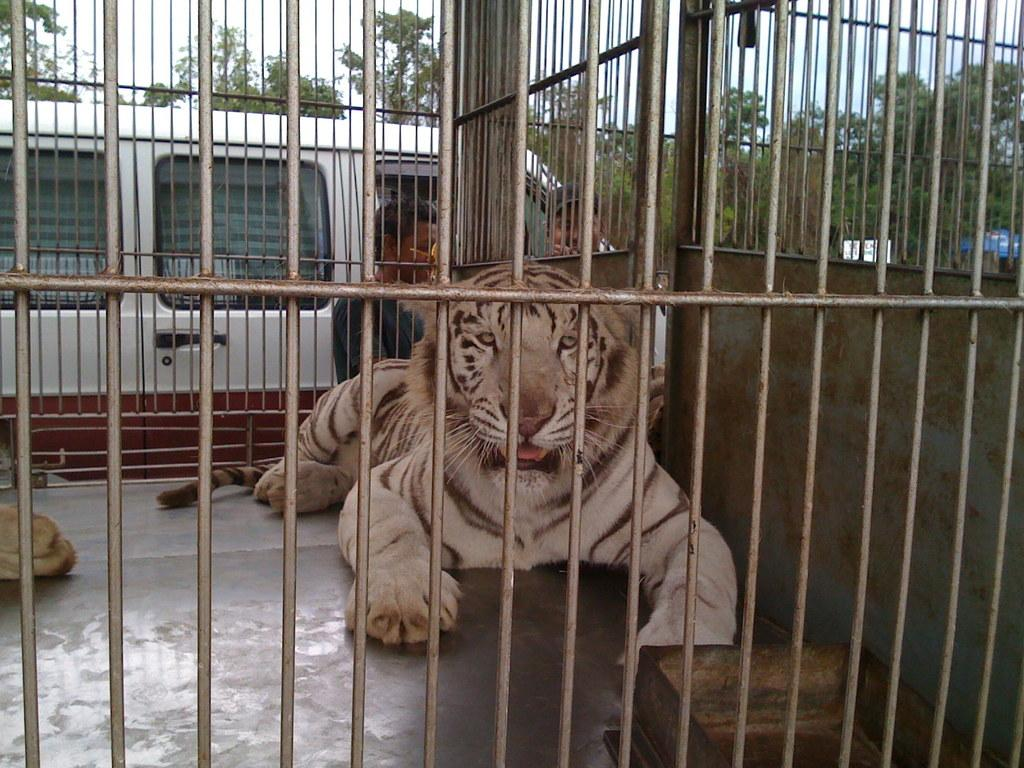What type of enclosure is present in the image? There is an iron cage in the image. What animal can be seen inside the cage? A white tiger is inside the cage. Can you describe the people in the background? There are two men standing in the background. What kind of vehicle is visible in the background? There is a white vehicle in the background. What type of natural scenery is present in the background? Trees are visible in the background. What type of stamp can be seen on the tiger's forehead in the image? There is no stamp visible on the tiger's forehead in the image. Can you recite a verse that is written on the cage in the image? There is no verse written on the cage in the image. 